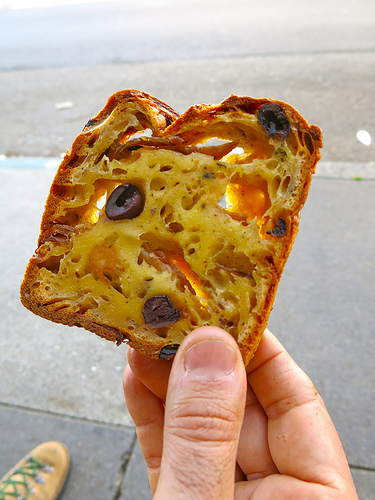<image>
Is the food on the man? Yes. Looking at the image, I can see the food is positioned on top of the man, with the man providing support. 